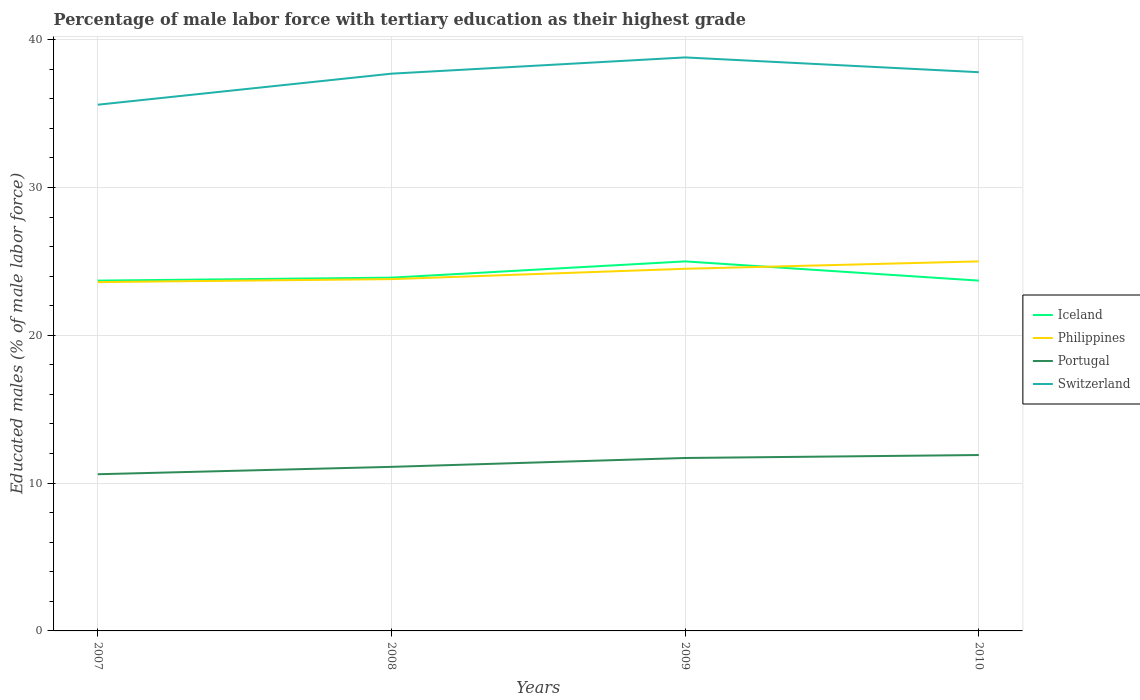How many different coloured lines are there?
Make the answer very short. 4. Does the line corresponding to Switzerland intersect with the line corresponding to Portugal?
Give a very brief answer. No. Is the number of lines equal to the number of legend labels?
Ensure brevity in your answer.  Yes. Across all years, what is the maximum percentage of male labor force with tertiary education in Iceland?
Keep it short and to the point. 23.7. In which year was the percentage of male labor force with tertiary education in Switzerland maximum?
Your answer should be very brief. 2007. What is the total percentage of male labor force with tertiary education in Portugal in the graph?
Provide a short and direct response. -1.3. What is the difference between the highest and the second highest percentage of male labor force with tertiary education in Portugal?
Your answer should be very brief. 1.3. What is the difference between the highest and the lowest percentage of male labor force with tertiary education in Iceland?
Your answer should be compact. 1. Is the percentage of male labor force with tertiary education in Iceland strictly greater than the percentage of male labor force with tertiary education in Switzerland over the years?
Your answer should be compact. Yes. How many legend labels are there?
Offer a very short reply. 4. What is the title of the graph?
Your answer should be very brief. Percentage of male labor force with tertiary education as their highest grade. What is the label or title of the Y-axis?
Provide a short and direct response. Educated males (% of male labor force). What is the Educated males (% of male labor force) of Iceland in 2007?
Offer a terse response. 23.7. What is the Educated males (% of male labor force) of Philippines in 2007?
Provide a succinct answer. 23.6. What is the Educated males (% of male labor force) of Portugal in 2007?
Provide a succinct answer. 10.6. What is the Educated males (% of male labor force) in Switzerland in 2007?
Ensure brevity in your answer.  35.6. What is the Educated males (% of male labor force) in Iceland in 2008?
Keep it short and to the point. 23.9. What is the Educated males (% of male labor force) in Philippines in 2008?
Ensure brevity in your answer.  23.8. What is the Educated males (% of male labor force) in Portugal in 2008?
Offer a very short reply. 11.1. What is the Educated males (% of male labor force) in Switzerland in 2008?
Offer a terse response. 37.7. What is the Educated males (% of male labor force) of Philippines in 2009?
Your answer should be compact. 24.5. What is the Educated males (% of male labor force) in Portugal in 2009?
Your answer should be very brief. 11.7. What is the Educated males (% of male labor force) of Switzerland in 2009?
Offer a very short reply. 38.8. What is the Educated males (% of male labor force) of Iceland in 2010?
Your answer should be compact. 23.7. What is the Educated males (% of male labor force) of Portugal in 2010?
Keep it short and to the point. 11.9. What is the Educated males (% of male labor force) in Switzerland in 2010?
Keep it short and to the point. 37.8. Across all years, what is the maximum Educated males (% of male labor force) in Portugal?
Your answer should be very brief. 11.9. Across all years, what is the maximum Educated males (% of male labor force) in Switzerland?
Offer a very short reply. 38.8. Across all years, what is the minimum Educated males (% of male labor force) in Iceland?
Provide a short and direct response. 23.7. Across all years, what is the minimum Educated males (% of male labor force) in Philippines?
Offer a very short reply. 23.6. Across all years, what is the minimum Educated males (% of male labor force) in Portugal?
Offer a terse response. 10.6. Across all years, what is the minimum Educated males (% of male labor force) in Switzerland?
Offer a very short reply. 35.6. What is the total Educated males (% of male labor force) in Iceland in the graph?
Keep it short and to the point. 96.3. What is the total Educated males (% of male labor force) in Philippines in the graph?
Provide a succinct answer. 96.9. What is the total Educated males (% of male labor force) of Portugal in the graph?
Make the answer very short. 45.3. What is the total Educated males (% of male labor force) in Switzerland in the graph?
Your response must be concise. 149.9. What is the difference between the Educated males (% of male labor force) of Philippines in 2007 and that in 2008?
Make the answer very short. -0.2. What is the difference between the Educated males (% of male labor force) in Portugal in 2007 and that in 2008?
Keep it short and to the point. -0.5. What is the difference between the Educated males (% of male labor force) in Iceland in 2007 and that in 2009?
Your answer should be very brief. -1.3. What is the difference between the Educated males (% of male labor force) of Portugal in 2007 and that in 2009?
Provide a succinct answer. -1.1. What is the difference between the Educated males (% of male labor force) in Switzerland in 2007 and that in 2009?
Provide a succinct answer. -3.2. What is the difference between the Educated males (% of male labor force) of Iceland in 2007 and that in 2010?
Give a very brief answer. 0. What is the difference between the Educated males (% of male labor force) in Philippines in 2007 and that in 2010?
Make the answer very short. -1.4. What is the difference between the Educated males (% of male labor force) in Iceland in 2008 and that in 2009?
Provide a succinct answer. -1.1. What is the difference between the Educated males (% of male labor force) in Philippines in 2008 and that in 2009?
Your response must be concise. -0.7. What is the difference between the Educated males (% of male labor force) in Iceland in 2008 and that in 2010?
Offer a very short reply. 0.2. What is the difference between the Educated males (% of male labor force) of Portugal in 2008 and that in 2010?
Your answer should be very brief. -0.8. What is the difference between the Educated males (% of male labor force) in Switzerland in 2008 and that in 2010?
Your answer should be compact. -0.1. What is the difference between the Educated males (% of male labor force) in Philippines in 2009 and that in 2010?
Make the answer very short. -0.5. What is the difference between the Educated males (% of male labor force) of Iceland in 2007 and the Educated males (% of male labor force) of Portugal in 2008?
Ensure brevity in your answer.  12.6. What is the difference between the Educated males (% of male labor force) of Philippines in 2007 and the Educated males (% of male labor force) of Portugal in 2008?
Offer a very short reply. 12.5. What is the difference between the Educated males (% of male labor force) of Philippines in 2007 and the Educated males (% of male labor force) of Switzerland in 2008?
Provide a short and direct response. -14.1. What is the difference between the Educated males (% of male labor force) in Portugal in 2007 and the Educated males (% of male labor force) in Switzerland in 2008?
Offer a very short reply. -27.1. What is the difference between the Educated males (% of male labor force) of Iceland in 2007 and the Educated males (% of male labor force) of Philippines in 2009?
Your answer should be very brief. -0.8. What is the difference between the Educated males (% of male labor force) of Iceland in 2007 and the Educated males (% of male labor force) of Portugal in 2009?
Offer a terse response. 12. What is the difference between the Educated males (% of male labor force) in Iceland in 2007 and the Educated males (% of male labor force) in Switzerland in 2009?
Provide a succinct answer. -15.1. What is the difference between the Educated males (% of male labor force) of Philippines in 2007 and the Educated males (% of male labor force) of Portugal in 2009?
Provide a short and direct response. 11.9. What is the difference between the Educated males (% of male labor force) in Philippines in 2007 and the Educated males (% of male labor force) in Switzerland in 2009?
Give a very brief answer. -15.2. What is the difference between the Educated males (% of male labor force) in Portugal in 2007 and the Educated males (% of male labor force) in Switzerland in 2009?
Make the answer very short. -28.2. What is the difference between the Educated males (% of male labor force) in Iceland in 2007 and the Educated males (% of male labor force) in Philippines in 2010?
Keep it short and to the point. -1.3. What is the difference between the Educated males (% of male labor force) in Iceland in 2007 and the Educated males (% of male labor force) in Switzerland in 2010?
Your answer should be compact. -14.1. What is the difference between the Educated males (% of male labor force) in Philippines in 2007 and the Educated males (% of male labor force) in Portugal in 2010?
Ensure brevity in your answer.  11.7. What is the difference between the Educated males (% of male labor force) in Philippines in 2007 and the Educated males (% of male labor force) in Switzerland in 2010?
Provide a short and direct response. -14.2. What is the difference between the Educated males (% of male labor force) in Portugal in 2007 and the Educated males (% of male labor force) in Switzerland in 2010?
Provide a succinct answer. -27.2. What is the difference between the Educated males (% of male labor force) of Iceland in 2008 and the Educated males (% of male labor force) of Philippines in 2009?
Your answer should be compact. -0.6. What is the difference between the Educated males (% of male labor force) of Iceland in 2008 and the Educated males (% of male labor force) of Portugal in 2009?
Offer a very short reply. 12.2. What is the difference between the Educated males (% of male labor force) in Iceland in 2008 and the Educated males (% of male labor force) in Switzerland in 2009?
Offer a terse response. -14.9. What is the difference between the Educated males (% of male labor force) in Philippines in 2008 and the Educated males (% of male labor force) in Portugal in 2009?
Your answer should be compact. 12.1. What is the difference between the Educated males (% of male labor force) in Portugal in 2008 and the Educated males (% of male labor force) in Switzerland in 2009?
Keep it short and to the point. -27.7. What is the difference between the Educated males (% of male labor force) in Iceland in 2008 and the Educated males (% of male labor force) in Philippines in 2010?
Provide a succinct answer. -1.1. What is the difference between the Educated males (% of male labor force) in Iceland in 2008 and the Educated males (% of male labor force) in Switzerland in 2010?
Offer a very short reply. -13.9. What is the difference between the Educated males (% of male labor force) in Portugal in 2008 and the Educated males (% of male labor force) in Switzerland in 2010?
Give a very brief answer. -26.7. What is the difference between the Educated males (% of male labor force) of Iceland in 2009 and the Educated males (% of male labor force) of Philippines in 2010?
Offer a terse response. 0. What is the difference between the Educated males (% of male labor force) of Iceland in 2009 and the Educated males (% of male labor force) of Portugal in 2010?
Give a very brief answer. 13.1. What is the difference between the Educated males (% of male labor force) in Philippines in 2009 and the Educated males (% of male labor force) in Portugal in 2010?
Your answer should be compact. 12.6. What is the difference between the Educated males (% of male labor force) of Philippines in 2009 and the Educated males (% of male labor force) of Switzerland in 2010?
Keep it short and to the point. -13.3. What is the difference between the Educated males (% of male labor force) of Portugal in 2009 and the Educated males (% of male labor force) of Switzerland in 2010?
Offer a terse response. -26.1. What is the average Educated males (% of male labor force) in Iceland per year?
Ensure brevity in your answer.  24.07. What is the average Educated males (% of male labor force) of Philippines per year?
Your answer should be compact. 24.23. What is the average Educated males (% of male labor force) in Portugal per year?
Provide a short and direct response. 11.32. What is the average Educated males (% of male labor force) in Switzerland per year?
Give a very brief answer. 37.48. In the year 2007, what is the difference between the Educated males (% of male labor force) of Iceland and Educated males (% of male labor force) of Switzerland?
Ensure brevity in your answer.  -11.9. In the year 2007, what is the difference between the Educated males (% of male labor force) of Philippines and Educated males (% of male labor force) of Switzerland?
Your answer should be very brief. -12. In the year 2007, what is the difference between the Educated males (% of male labor force) in Portugal and Educated males (% of male labor force) in Switzerland?
Your answer should be very brief. -25. In the year 2008, what is the difference between the Educated males (% of male labor force) in Iceland and Educated males (% of male labor force) in Philippines?
Your answer should be very brief. 0.1. In the year 2008, what is the difference between the Educated males (% of male labor force) in Iceland and Educated males (% of male labor force) in Portugal?
Keep it short and to the point. 12.8. In the year 2008, what is the difference between the Educated males (% of male labor force) in Iceland and Educated males (% of male labor force) in Switzerland?
Ensure brevity in your answer.  -13.8. In the year 2008, what is the difference between the Educated males (% of male labor force) of Portugal and Educated males (% of male labor force) of Switzerland?
Provide a succinct answer. -26.6. In the year 2009, what is the difference between the Educated males (% of male labor force) of Iceland and Educated males (% of male labor force) of Philippines?
Provide a succinct answer. 0.5. In the year 2009, what is the difference between the Educated males (% of male labor force) in Iceland and Educated males (% of male labor force) in Switzerland?
Provide a succinct answer. -13.8. In the year 2009, what is the difference between the Educated males (% of male labor force) in Philippines and Educated males (% of male labor force) in Switzerland?
Keep it short and to the point. -14.3. In the year 2009, what is the difference between the Educated males (% of male labor force) of Portugal and Educated males (% of male labor force) of Switzerland?
Offer a very short reply. -27.1. In the year 2010, what is the difference between the Educated males (% of male labor force) in Iceland and Educated males (% of male labor force) in Switzerland?
Your response must be concise. -14.1. In the year 2010, what is the difference between the Educated males (% of male labor force) in Philippines and Educated males (% of male labor force) in Portugal?
Make the answer very short. 13.1. In the year 2010, what is the difference between the Educated males (% of male labor force) in Philippines and Educated males (% of male labor force) in Switzerland?
Provide a succinct answer. -12.8. In the year 2010, what is the difference between the Educated males (% of male labor force) in Portugal and Educated males (% of male labor force) in Switzerland?
Your answer should be very brief. -25.9. What is the ratio of the Educated males (% of male labor force) in Philippines in 2007 to that in 2008?
Ensure brevity in your answer.  0.99. What is the ratio of the Educated males (% of male labor force) in Portugal in 2007 to that in 2008?
Make the answer very short. 0.95. What is the ratio of the Educated males (% of male labor force) in Switzerland in 2007 to that in 2008?
Your answer should be very brief. 0.94. What is the ratio of the Educated males (% of male labor force) of Iceland in 2007 to that in 2009?
Ensure brevity in your answer.  0.95. What is the ratio of the Educated males (% of male labor force) of Philippines in 2007 to that in 2009?
Your response must be concise. 0.96. What is the ratio of the Educated males (% of male labor force) in Portugal in 2007 to that in 2009?
Your answer should be very brief. 0.91. What is the ratio of the Educated males (% of male labor force) in Switzerland in 2007 to that in 2009?
Your answer should be compact. 0.92. What is the ratio of the Educated males (% of male labor force) of Philippines in 2007 to that in 2010?
Offer a very short reply. 0.94. What is the ratio of the Educated males (% of male labor force) of Portugal in 2007 to that in 2010?
Provide a short and direct response. 0.89. What is the ratio of the Educated males (% of male labor force) of Switzerland in 2007 to that in 2010?
Ensure brevity in your answer.  0.94. What is the ratio of the Educated males (% of male labor force) in Iceland in 2008 to that in 2009?
Your answer should be compact. 0.96. What is the ratio of the Educated males (% of male labor force) of Philippines in 2008 to that in 2009?
Ensure brevity in your answer.  0.97. What is the ratio of the Educated males (% of male labor force) in Portugal in 2008 to that in 2009?
Your answer should be compact. 0.95. What is the ratio of the Educated males (% of male labor force) of Switzerland in 2008 to that in 2009?
Make the answer very short. 0.97. What is the ratio of the Educated males (% of male labor force) in Iceland in 2008 to that in 2010?
Offer a very short reply. 1.01. What is the ratio of the Educated males (% of male labor force) of Philippines in 2008 to that in 2010?
Offer a very short reply. 0.95. What is the ratio of the Educated males (% of male labor force) of Portugal in 2008 to that in 2010?
Keep it short and to the point. 0.93. What is the ratio of the Educated males (% of male labor force) in Switzerland in 2008 to that in 2010?
Give a very brief answer. 1. What is the ratio of the Educated males (% of male labor force) in Iceland in 2009 to that in 2010?
Provide a short and direct response. 1.05. What is the ratio of the Educated males (% of male labor force) in Portugal in 2009 to that in 2010?
Make the answer very short. 0.98. What is the ratio of the Educated males (% of male labor force) in Switzerland in 2009 to that in 2010?
Your answer should be compact. 1.03. What is the difference between the highest and the second highest Educated males (% of male labor force) of Iceland?
Your response must be concise. 1.1. What is the difference between the highest and the second highest Educated males (% of male labor force) of Philippines?
Your answer should be very brief. 0.5. What is the difference between the highest and the lowest Educated males (% of male labor force) in Philippines?
Offer a very short reply. 1.4. What is the difference between the highest and the lowest Educated males (% of male labor force) of Portugal?
Your answer should be compact. 1.3. What is the difference between the highest and the lowest Educated males (% of male labor force) of Switzerland?
Make the answer very short. 3.2. 